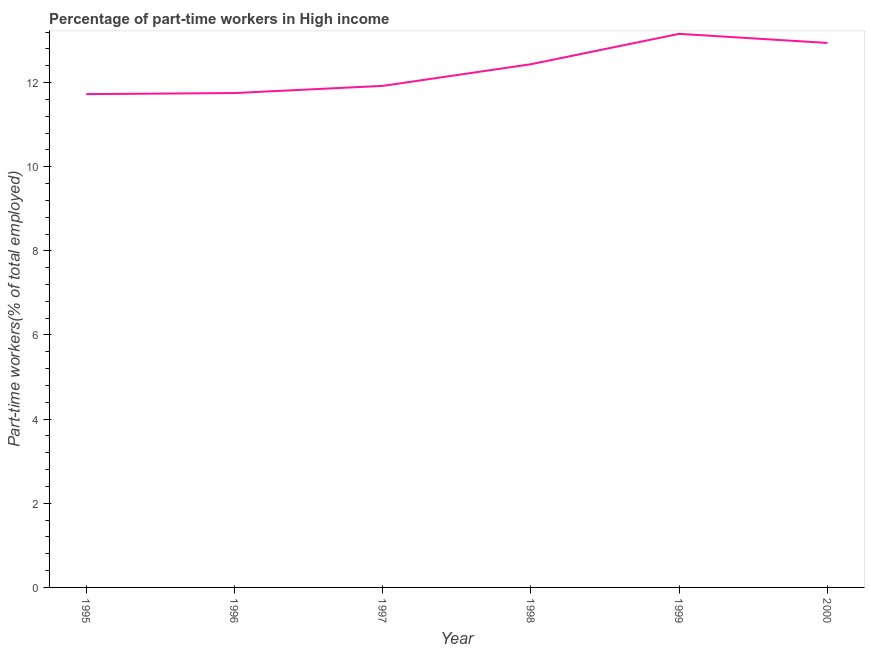What is the percentage of part-time workers in 1996?
Offer a very short reply. 11.75. Across all years, what is the maximum percentage of part-time workers?
Your answer should be compact. 13.16. Across all years, what is the minimum percentage of part-time workers?
Keep it short and to the point. 11.73. In which year was the percentage of part-time workers maximum?
Provide a short and direct response. 1999. In which year was the percentage of part-time workers minimum?
Provide a succinct answer. 1995. What is the sum of the percentage of part-time workers?
Ensure brevity in your answer.  73.93. What is the difference between the percentage of part-time workers in 1998 and 2000?
Provide a succinct answer. -0.51. What is the average percentage of part-time workers per year?
Make the answer very short. 12.32. What is the median percentage of part-time workers?
Give a very brief answer. 12.18. In how many years, is the percentage of part-time workers greater than 3.2 %?
Your answer should be very brief. 6. What is the ratio of the percentage of part-time workers in 1999 to that in 2000?
Your answer should be very brief. 1.02. What is the difference between the highest and the second highest percentage of part-time workers?
Ensure brevity in your answer.  0.22. What is the difference between the highest and the lowest percentage of part-time workers?
Provide a succinct answer. 1.43. Does the percentage of part-time workers monotonically increase over the years?
Keep it short and to the point. No. How many years are there in the graph?
Make the answer very short. 6. Are the values on the major ticks of Y-axis written in scientific E-notation?
Your response must be concise. No. What is the title of the graph?
Keep it short and to the point. Percentage of part-time workers in High income. What is the label or title of the X-axis?
Offer a terse response. Year. What is the label or title of the Y-axis?
Offer a terse response. Part-time workers(% of total employed). What is the Part-time workers(% of total employed) in 1995?
Your response must be concise. 11.73. What is the Part-time workers(% of total employed) in 1996?
Make the answer very short. 11.75. What is the Part-time workers(% of total employed) of 1997?
Offer a very short reply. 11.92. What is the Part-time workers(% of total employed) of 1998?
Offer a very short reply. 12.44. What is the Part-time workers(% of total employed) of 1999?
Your answer should be compact. 13.16. What is the Part-time workers(% of total employed) of 2000?
Keep it short and to the point. 12.94. What is the difference between the Part-time workers(% of total employed) in 1995 and 1996?
Ensure brevity in your answer.  -0.03. What is the difference between the Part-time workers(% of total employed) in 1995 and 1997?
Offer a terse response. -0.2. What is the difference between the Part-time workers(% of total employed) in 1995 and 1998?
Give a very brief answer. -0.71. What is the difference between the Part-time workers(% of total employed) in 1995 and 1999?
Provide a short and direct response. -1.43. What is the difference between the Part-time workers(% of total employed) in 1995 and 2000?
Your answer should be compact. -1.22. What is the difference between the Part-time workers(% of total employed) in 1996 and 1997?
Your response must be concise. -0.17. What is the difference between the Part-time workers(% of total employed) in 1996 and 1998?
Offer a very short reply. -0.68. What is the difference between the Part-time workers(% of total employed) in 1996 and 1999?
Make the answer very short. -1.41. What is the difference between the Part-time workers(% of total employed) in 1996 and 2000?
Offer a terse response. -1.19. What is the difference between the Part-time workers(% of total employed) in 1997 and 1998?
Keep it short and to the point. -0.51. What is the difference between the Part-time workers(% of total employed) in 1997 and 1999?
Offer a terse response. -1.24. What is the difference between the Part-time workers(% of total employed) in 1997 and 2000?
Ensure brevity in your answer.  -1.02. What is the difference between the Part-time workers(% of total employed) in 1998 and 1999?
Keep it short and to the point. -0.72. What is the difference between the Part-time workers(% of total employed) in 1998 and 2000?
Your answer should be compact. -0.51. What is the difference between the Part-time workers(% of total employed) in 1999 and 2000?
Keep it short and to the point. 0.22. What is the ratio of the Part-time workers(% of total employed) in 1995 to that in 1996?
Ensure brevity in your answer.  1. What is the ratio of the Part-time workers(% of total employed) in 1995 to that in 1997?
Give a very brief answer. 0.98. What is the ratio of the Part-time workers(% of total employed) in 1995 to that in 1998?
Keep it short and to the point. 0.94. What is the ratio of the Part-time workers(% of total employed) in 1995 to that in 1999?
Your answer should be very brief. 0.89. What is the ratio of the Part-time workers(% of total employed) in 1995 to that in 2000?
Your response must be concise. 0.91. What is the ratio of the Part-time workers(% of total employed) in 1996 to that in 1998?
Offer a terse response. 0.94. What is the ratio of the Part-time workers(% of total employed) in 1996 to that in 1999?
Offer a terse response. 0.89. What is the ratio of the Part-time workers(% of total employed) in 1996 to that in 2000?
Your answer should be very brief. 0.91. What is the ratio of the Part-time workers(% of total employed) in 1997 to that in 1999?
Provide a short and direct response. 0.91. What is the ratio of the Part-time workers(% of total employed) in 1997 to that in 2000?
Offer a very short reply. 0.92. What is the ratio of the Part-time workers(% of total employed) in 1998 to that in 1999?
Your response must be concise. 0.94. What is the ratio of the Part-time workers(% of total employed) in 1998 to that in 2000?
Give a very brief answer. 0.96. What is the ratio of the Part-time workers(% of total employed) in 1999 to that in 2000?
Your response must be concise. 1.02. 